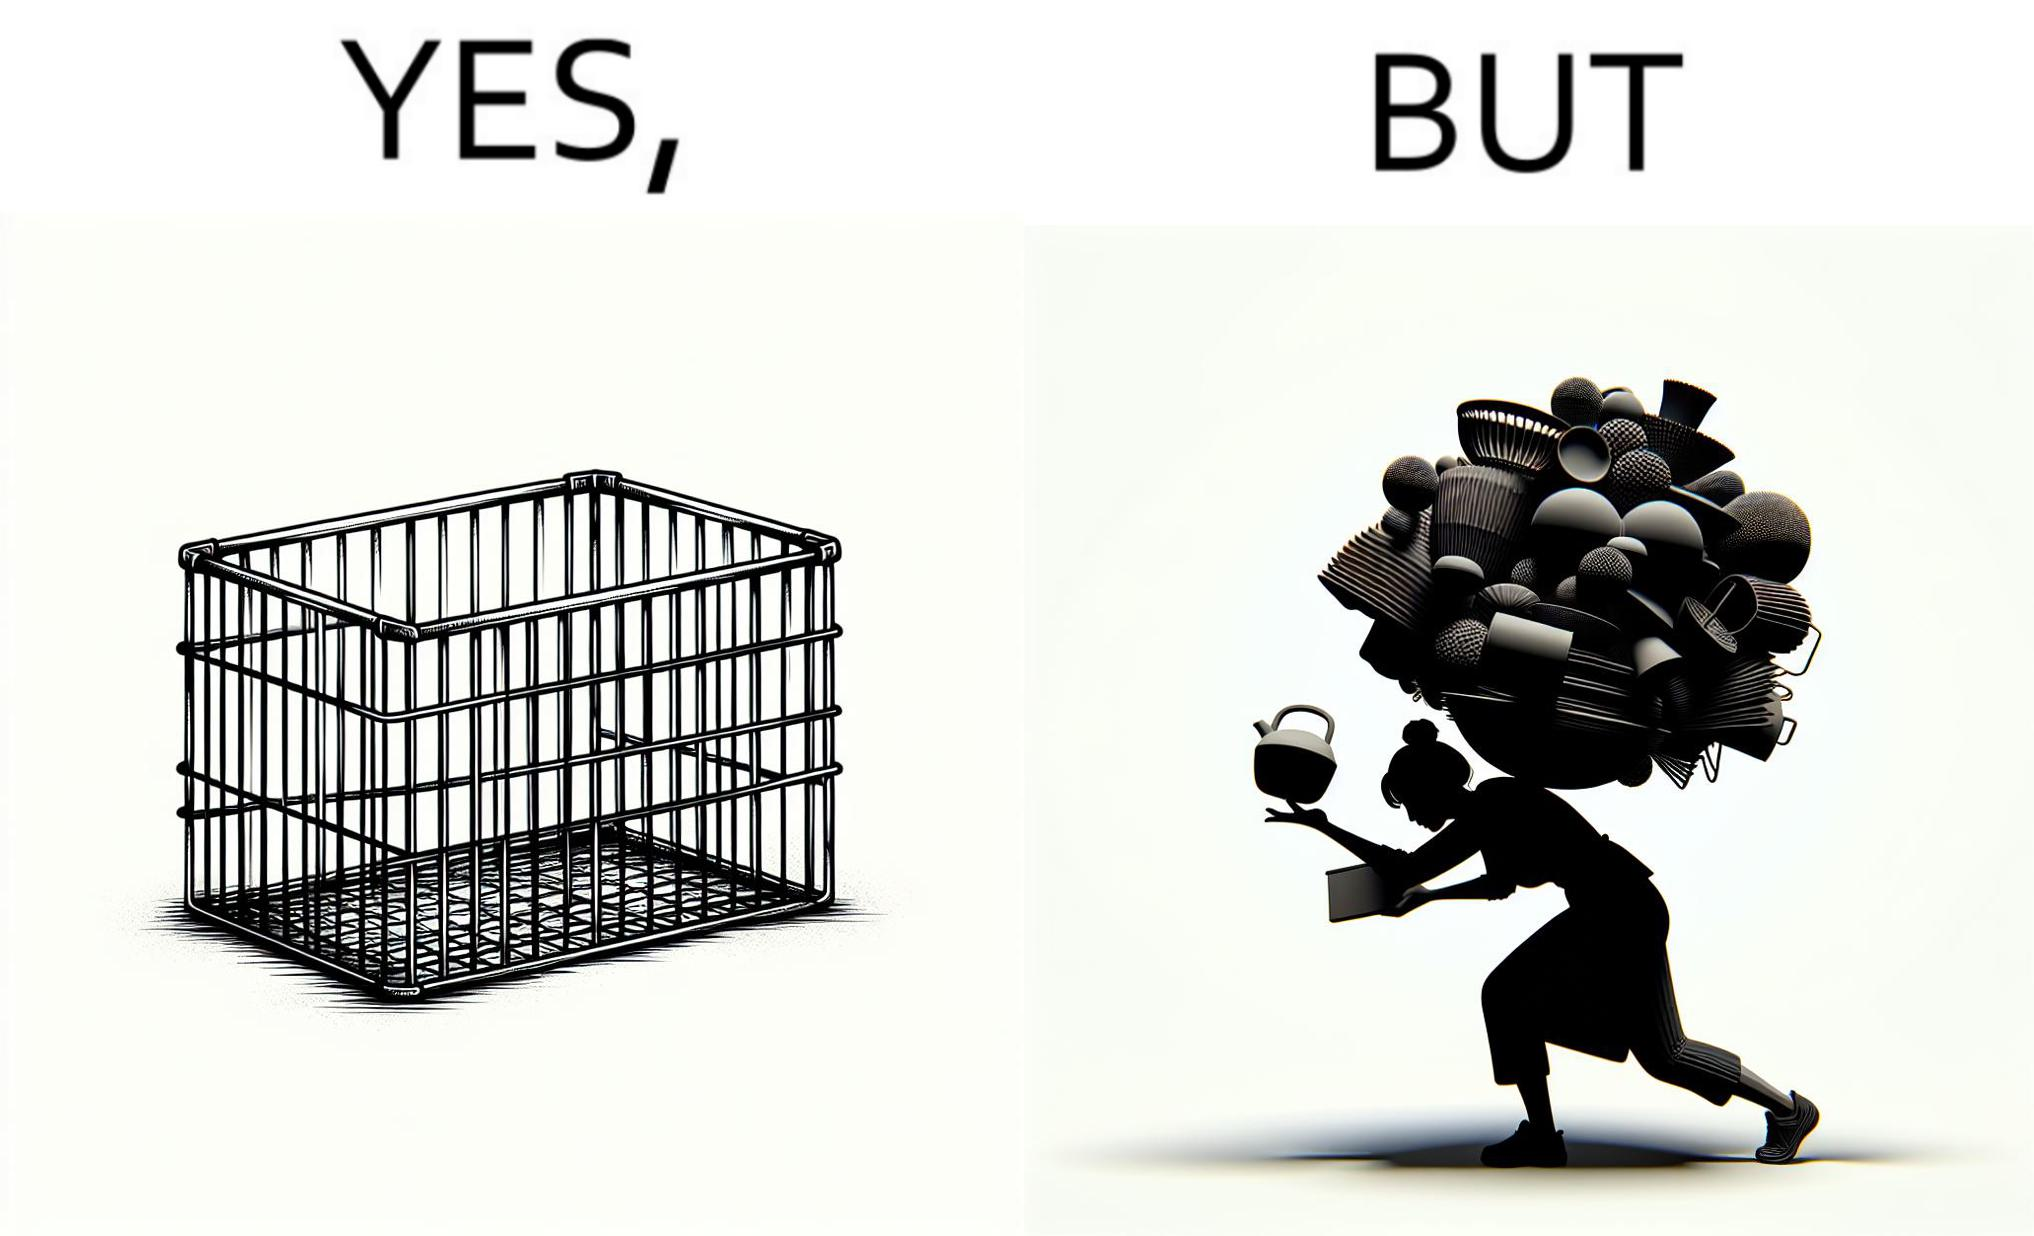Describe the satirical element in this image. The image is ironic, because even when there are steel frame baskets are available at the supermarkets people prefer carrying the items in hand 